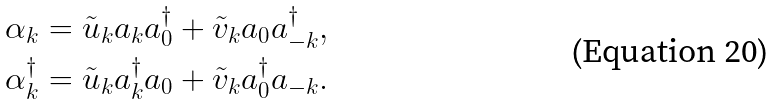<formula> <loc_0><loc_0><loc_500><loc_500>& \alpha _ { k } = \tilde { u } _ { k } a _ { k } a _ { 0 } ^ { \dagger } + \tilde { v } _ { k } a _ { 0 } a ^ { \dagger } _ { - k } , \\ & \alpha _ { k } ^ { \dagger } = \tilde { u } _ { k } a _ { k } ^ { \dagger } a _ { 0 } + \tilde { v } _ { k } a _ { 0 } ^ { \dagger } a _ { - k } .</formula> 